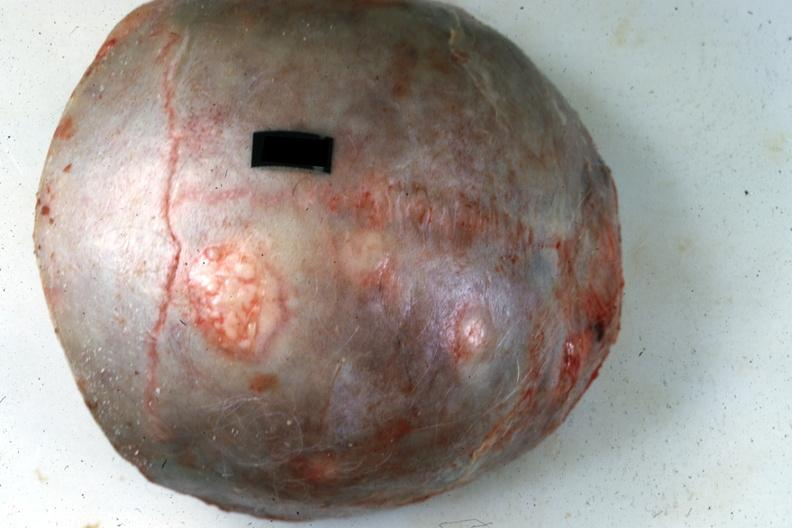what does this image show?
Answer the question using a single word or phrase. Top of calvaria typical lesions source 